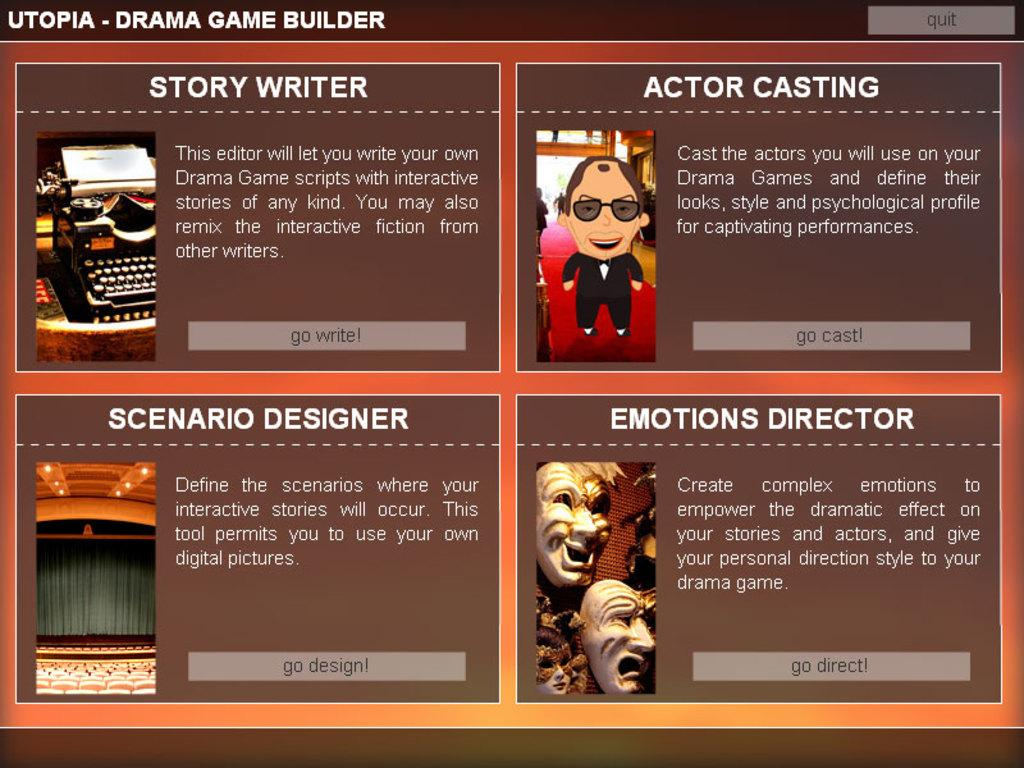What is the source of the image? The image is a photocopy of a screen. What can be seen on the screen that was photocopied? There is text and images visible in the image. What type of garden is visible in the image? There is no garden present in the image; it is a photocopy of a screen with text and images. 